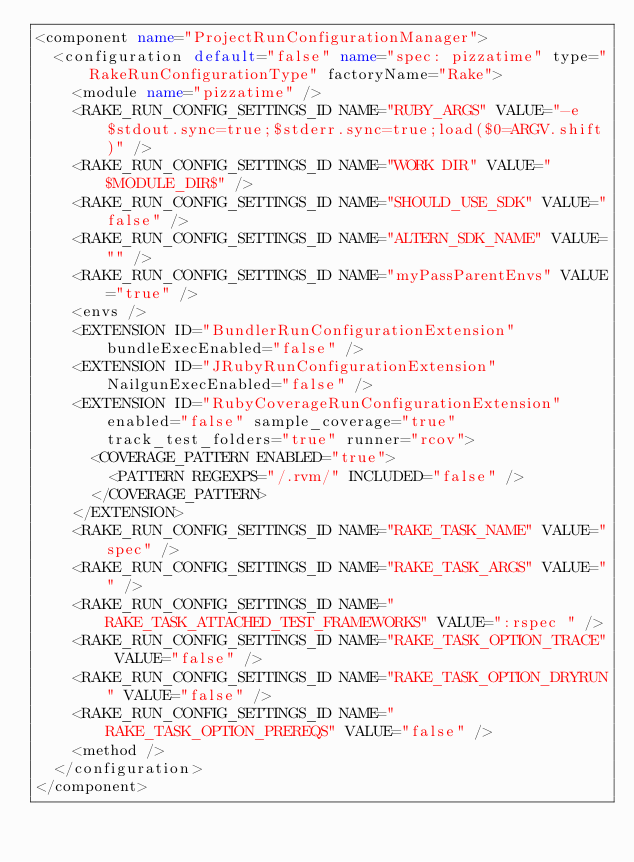<code> <loc_0><loc_0><loc_500><loc_500><_XML_><component name="ProjectRunConfigurationManager">
  <configuration default="false" name="spec: pizzatime" type="RakeRunConfigurationType" factoryName="Rake">
    <module name="pizzatime" />
    <RAKE_RUN_CONFIG_SETTINGS_ID NAME="RUBY_ARGS" VALUE="-e $stdout.sync=true;$stderr.sync=true;load($0=ARGV.shift)" />
    <RAKE_RUN_CONFIG_SETTINGS_ID NAME="WORK DIR" VALUE="$MODULE_DIR$" />
    <RAKE_RUN_CONFIG_SETTINGS_ID NAME="SHOULD_USE_SDK" VALUE="false" />
    <RAKE_RUN_CONFIG_SETTINGS_ID NAME="ALTERN_SDK_NAME" VALUE="" />
    <RAKE_RUN_CONFIG_SETTINGS_ID NAME="myPassParentEnvs" VALUE="true" />
    <envs />
    <EXTENSION ID="BundlerRunConfigurationExtension" bundleExecEnabled="false" />
    <EXTENSION ID="JRubyRunConfigurationExtension" NailgunExecEnabled="false" />
    <EXTENSION ID="RubyCoverageRunConfigurationExtension" enabled="false" sample_coverage="true" track_test_folders="true" runner="rcov">
      <COVERAGE_PATTERN ENABLED="true">
        <PATTERN REGEXPS="/.rvm/" INCLUDED="false" />
      </COVERAGE_PATTERN>
    </EXTENSION>
    <RAKE_RUN_CONFIG_SETTINGS_ID NAME="RAKE_TASK_NAME" VALUE="spec" />
    <RAKE_RUN_CONFIG_SETTINGS_ID NAME="RAKE_TASK_ARGS" VALUE="" />
    <RAKE_RUN_CONFIG_SETTINGS_ID NAME="RAKE_TASK_ATTACHED_TEST_FRAMEWORKS" VALUE=":rspec " />
    <RAKE_RUN_CONFIG_SETTINGS_ID NAME="RAKE_TASK_OPTION_TRACE" VALUE="false" />
    <RAKE_RUN_CONFIG_SETTINGS_ID NAME="RAKE_TASK_OPTION_DRYRUN" VALUE="false" />
    <RAKE_RUN_CONFIG_SETTINGS_ID NAME="RAKE_TASK_OPTION_PREREQS" VALUE="false" />
    <method />
  </configuration>
</component></code> 